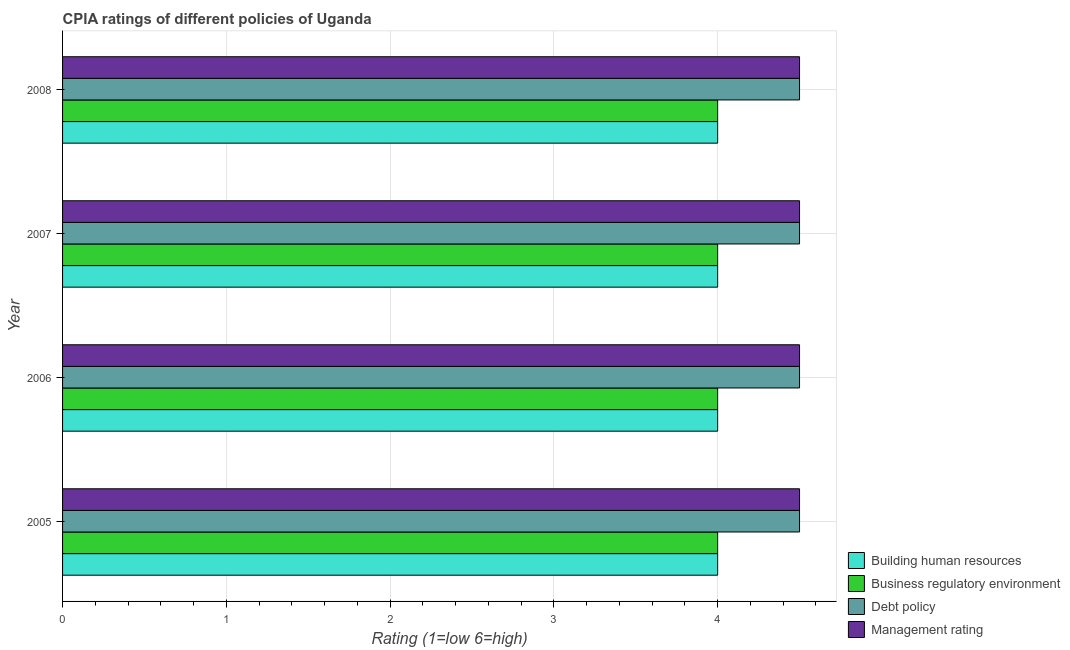Are the number of bars per tick equal to the number of legend labels?
Provide a short and direct response. Yes. How many bars are there on the 1st tick from the top?
Keep it short and to the point. 4. How many bars are there on the 4th tick from the bottom?
Ensure brevity in your answer.  4. In how many cases, is the number of bars for a given year not equal to the number of legend labels?
Ensure brevity in your answer.  0. What is the cpia rating of business regulatory environment in 2008?
Offer a very short reply. 4. Across all years, what is the maximum cpia rating of management?
Your response must be concise. 4.5. In which year was the cpia rating of debt policy minimum?
Your answer should be very brief. 2005. What is the total cpia rating of business regulatory environment in the graph?
Give a very brief answer. 16. What is the difference between the cpia rating of building human resources in 2005 and that in 2007?
Make the answer very short. 0. What is the average cpia rating of business regulatory environment per year?
Your answer should be compact. 4. Is the difference between the cpia rating of business regulatory environment in 2005 and 2006 greater than the difference between the cpia rating of building human resources in 2005 and 2006?
Offer a terse response. No. What does the 2nd bar from the top in 2008 represents?
Your answer should be compact. Debt policy. What does the 4th bar from the bottom in 2006 represents?
Provide a short and direct response. Management rating. Is it the case that in every year, the sum of the cpia rating of building human resources and cpia rating of business regulatory environment is greater than the cpia rating of debt policy?
Provide a short and direct response. Yes. How many years are there in the graph?
Your answer should be very brief. 4. Are the values on the major ticks of X-axis written in scientific E-notation?
Make the answer very short. No. Where does the legend appear in the graph?
Your answer should be compact. Bottom right. How are the legend labels stacked?
Keep it short and to the point. Vertical. What is the title of the graph?
Make the answer very short. CPIA ratings of different policies of Uganda. What is the Rating (1=low 6=high) of Management rating in 2005?
Make the answer very short. 4.5. What is the Rating (1=low 6=high) in Building human resources in 2006?
Ensure brevity in your answer.  4. What is the Rating (1=low 6=high) in Management rating in 2006?
Offer a terse response. 4.5. What is the Rating (1=low 6=high) in Building human resources in 2008?
Your response must be concise. 4. What is the Rating (1=low 6=high) in Debt policy in 2008?
Provide a succinct answer. 4.5. Across all years, what is the minimum Rating (1=low 6=high) of Building human resources?
Provide a succinct answer. 4. Across all years, what is the minimum Rating (1=low 6=high) of Business regulatory environment?
Offer a very short reply. 4. What is the total Rating (1=low 6=high) of Building human resources in the graph?
Keep it short and to the point. 16. What is the total Rating (1=low 6=high) of Management rating in the graph?
Your answer should be compact. 18. What is the difference between the Rating (1=low 6=high) in Management rating in 2005 and that in 2007?
Your response must be concise. 0. What is the difference between the Rating (1=low 6=high) in Building human resources in 2005 and that in 2008?
Offer a very short reply. 0. What is the difference between the Rating (1=low 6=high) in Business regulatory environment in 2005 and that in 2008?
Provide a succinct answer. 0. What is the difference between the Rating (1=low 6=high) of Debt policy in 2006 and that in 2007?
Offer a very short reply. 0. What is the difference between the Rating (1=low 6=high) of Business regulatory environment in 2006 and that in 2008?
Provide a short and direct response. 0. What is the difference between the Rating (1=low 6=high) of Building human resources in 2007 and that in 2008?
Your answer should be very brief. 0. What is the difference between the Rating (1=low 6=high) of Management rating in 2007 and that in 2008?
Your answer should be very brief. 0. What is the difference between the Rating (1=low 6=high) in Building human resources in 2005 and the Rating (1=low 6=high) in Management rating in 2006?
Make the answer very short. -0.5. What is the difference between the Rating (1=low 6=high) in Building human resources in 2005 and the Rating (1=low 6=high) in Debt policy in 2007?
Provide a short and direct response. -0.5. What is the difference between the Rating (1=low 6=high) of Building human resources in 2005 and the Rating (1=low 6=high) of Business regulatory environment in 2008?
Offer a terse response. 0. What is the difference between the Rating (1=low 6=high) of Building human resources in 2005 and the Rating (1=low 6=high) of Debt policy in 2008?
Your answer should be very brief. -0.5. What is the difference between the Rating (1=low 6=high) in Building human resources in 2005 and the Rating (1=low 6=high) in Management rating in 2008?
Ensure brevity in your answer.  -0.5. What is the difference between the Rating (1=low 6=high) in Building human resources in 2006 and the Rating (1=low 6=high) in Business regulatory environment in 2007?
Offer a terse response. 0. What is the difference between the Rating (1=low 6=high) in Building human resources in 2006 and the Rating (1=low 6=high) in Debt policy in 2007?
Give a very brief answer. -0.5. What is the difference between the Rating (1=low 6=high) of Building human resources in 2006 and the Rating (1=low 6=high) of Management rating in 2007?
Keep it short and to the point. -0.5. What is the difference between the Rating (1=low 6=high) of Business regulatory environment in 2006 and the Rating (1=low 6=high) of Debt policy in 2007?
Your response must be concise. -0.5. What is the difference between the Rating (1=low 6=high) of Debt policy in 2006 and the Rating (1=low 6=high) of Management rating in 2007?
Your answer should be compact. 0. What is the difference between the Rating (1=low 6=high) in Building human resources in 2006 and the Rating (1=low 6=high) in Business regulatory environment in 2008?
Keep it short and to the point. 0. What is the difference between the Rating (1=low 6=high) in Building human resources in 2006 and the Rating (1=low 6=high) in Management rating in 2008?
Ensure brevity in your answer.  -0.5. What is the difference between the Rating (1=low 6=high) in Business regulatory environment in 2006 and the Rating (1=low 6=high) in Debt policy in 2008?
Provide a succinct answer. -0.5. What is the difference between the Rating (1=low 6=high) of Debt policy in 2006 and the Rating (1=low 6=high) of Management rating in 2008?
Make the answer very short. 0. What is the difference between the Rating (1=low 6=high) in Building human resources in 2007 and the Rating (1=low 6=high) in Business regulatory environment in 2008?
Your answer should be very brief. 0. What is the difference between the Rating (1=low 6=high) in Building human resources in 2007 and the Rating (1=low 6=high) in Debt policy in 2008?
Your answer should be compact. -0.5. What is the difference between the Rating (1=low 6=high) in Business regulatory environment in 2007 and the Rating (1=low 6=high) in Debt policy in 2008?
Make the answer very short. -0.5. What is the difference between the Rating (1=low 6=high) of Business regulatory environment in 2007 and the Rating (1=low 6=high) of Management rating in 2008?
Make the answer very short. -0.5. What is the difference between the Rating (1=low 6=high) of Debt policy in 2007 and the Rating (1=low 6=high) of Management rating in 2008?
Give a very brief answer. 0. What is the average Rating (1=low 6=high) in Building human resources per year?
Offer a very short reply. 4. In the year 2005, what is the difference between the Rating (1=low 6=high) of Building human resources and Rating (1=low 6=high) of Business regulatory environment?
Your response must be concise. 0. In the year 2005, what is the difference between the Rating (1=low 6=high) in Building human resources and Rating (1=low 6=high) in Debt policy?
Offer a terse response. -0.5. In the year 2005, what is the difference between the Rating (1=low 6=high) in Debt policy and Rating (1=low 6=high) in Management rating?
Your answer should be compact. 0. In the year 2006, what is the difference between the Rating (1=low 6=high) of Building human resources and Rating (1=low 6=high) of Business regulatory environment?
Offer a terse response. 0. In the year 2006, what is the difference between the Rating (1=low 6=high) in Building human resources and Rating (1=low 6=high) in Debt policy?
Keep it short and to the point. -0.5. In the year 2006, what is the difference between the Rating (1=low 6=high) in Business regulatory environment and Rating (1=low 6=high) in Debt policy?
Your answer should be compact. -0.5. In the year 2006, what is the difference between the Rating (1=low 6=high) in Debt policy and Rating (1=low 6=high) in Management rating?
Your answer should be compact. 0. In the year 2007, what is the difference between the Rating (1=low 6=high) of Building human resources and Rating (1=low 6=high) of Business regulatory environment?
Your answer should be compact. 0. In the year 2007, what is the difference between the Rating (1=low 6=high) of Building human resources and Rating (1=low 6=high) of Debt policy?
Provide a succinct answer. -0.5. In the year 2007, what is the difference between the Rating (1=low 6=high) of Building human resources and Rating (1=low 6=high) of Management rating?
Your answer should be compact. -0.5. In the year 2007, what is the difference between the Rating (1=low 6=high) of Business regulatory environment and Rating (1=low 6=high) of Management rating?
Ensure brevity in your answer.  -0.5. In the year 2008, what is the difference between the Rating (1=low 6=high) in Building human resources and Rating (1=low 6=high) in Management rating?
Keep it short and to the point. -0.5. In the year 2008, what is the difference between the Rating (1=low 6=high) in Business regulatory environment and Rating (1=low 6=high) in Debt policy?
Ensure brevity in your answer.  -0.5. What is the ratio of the Rating (1=low 6=high) of Building human resources in 2005 to that in 2007?
Give a very brief answer. 1. What is the ratio of the Rating (1=low 6=high) of Management rating in 2005 to that in 2007?
Offer a terse response. 1. What is the ratio of the Rating (1=low 6=high) of Building human resources in 2005 to that in 2008?
Your answer should be compact. 1. What is the ratio of the Rating (1=low 6=high) of Debt policy in 2005 to that in 2008?
Provide a succinct answer. 1. What is the ratio of the Rating (1=low 6=high) in Management rating in 2005 to that in 2008?
Your answer should be compact. 1. What is the ratio of the Rating (1=low 6=high) in Business regulatory environment in 2006 to that in 2007?
Provide a short and direct response. 1. What is the ratio of the Rating (1=low 6=high) in Management rating in 2006 to that in 2007?
Offer a very short reply. 1. What is the ratio of the Rating (1=low 6=high) of Building human resources in 2006 to that in 2008?
Provide a short and direct response. 1. What is the ratio of the Rating (1=low 6=high) in Business regulatory environment in 2006 to that in 2008?
Provide a short and direct response. 1. What is the ratio of the Rating (1=low 6=high) of Building human resources in 2007 to that in 2008?
Your answer should be very brief. 1. What is the ratio of the Rating (1=low 6=high) in Debt policy in 2007 to that in 2008?
Keep it short and to the point. 1. What is the ratio of the Rating (1=low 6=high) in Management rating in 2007 to that in 2008?
Give a very brief answer. 1. What is the difference between the highest and the second highest Rating (1=low 6=high) of Building human resources?
Provide a succinct answer. 0. What is the difference between the highest and the second highest Rating (1=low 6=high) of Business regulatory environment?
Provide a short and direct response. 0. What is the difference between the highest and the second highest Rating (1=low 6=high) in Debt policy?
Your response must be concise. 0. What is the difference between the highest and the lowest Rating (1=low 6=high) in Building human resources?
Offer a terse response. 0. What is the difference between the highest and the lowest Rating (1=low 6=high) in Debt policy?
Provide a succinct answer. 0. 